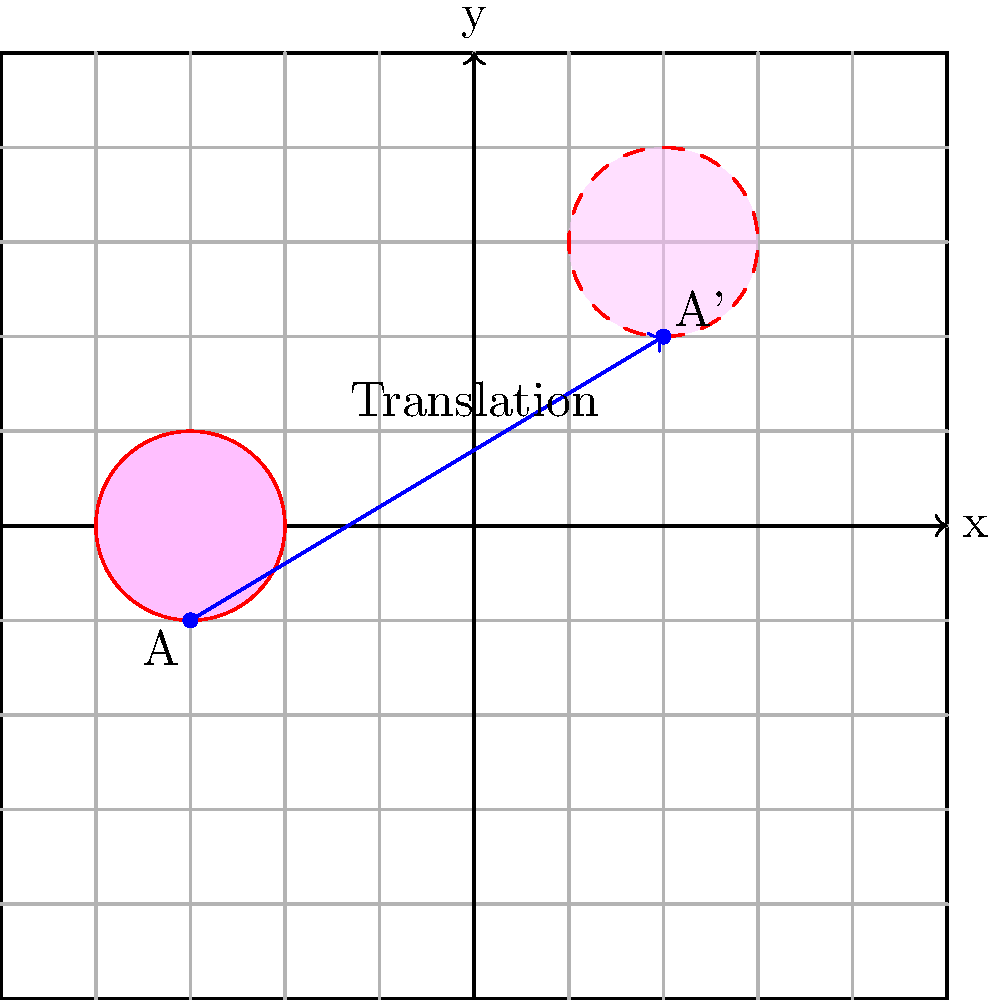In the coordinate plane above, a heart shape centered at point A(-3, -1) is translated to a new position centered at point A'(2, 2). What is the translation vector that describes this movement? To find the translation vector, we need to follow these steps:

1. Identify the initial and final positions:
   - Initial position (point A): (-3, -1)
   - Final position (point A'): (2, 2)

2. Calculate the change in x-coordinate:
   $\Delta x = x_{final} - x_{initial} = 2 - (-3) = 2 + 3 = 5$

3. Calculate the change in y-coordinate:
   $\Delta y = y_{final} - y_{initial} = 2 - (-1) = 2 + 1 = 3$

4. Express the translation vector as an ordered pair:
   Translation vector = $(\Delta x, \Delta y) = (5, 3)$

This vector represents the movement of 5 units right and 3 units up, which transforms the heart from its original position to its new position.
Answer: (5, 3) 